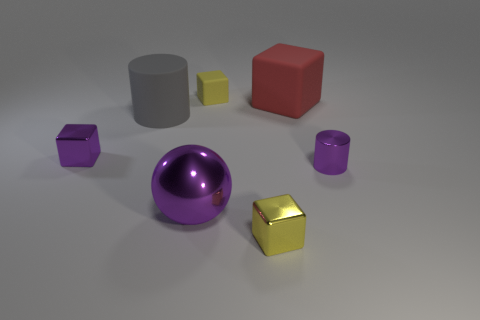Is there any other thing that is the same shape as the big shiny thing?
Ensure brevity in your answer.  No. How many tiny matte blocks are in front of the large red matte block?
Offer a terse response. 0. How many large spheres are made of the same material as the big gray cylinder?
Make the answer very short. 0. What is the color of the cylinder that is made of the same material as the red block?
Your answer should be very brief. Gray. What is the yellow cube that is behind the tiny purple thing on the left side of the yellow block behind the large red object made of?
Give a very brief answer. Rubber. Does the yellow thing that is on the right side of the yellow rubber cube have the same size as the gray rubber cylinder?
Your response must be concise. No. What number of tiny things are purple shiny blocks or gray rubber things?
Your response must be concise. 1. Are there any small cylinders that have the same color as the metallic sphere?
Keep it short and to the point. Yes. There is a yellow matte object that is the same size as the yellow metal thing; what is its shape?
Your response must be concise. Cube. There is a small shiny cube that is right of the purple metallic ball; does it have the same color as the tiny rubber block?
Your answer should be compact. Yes. 